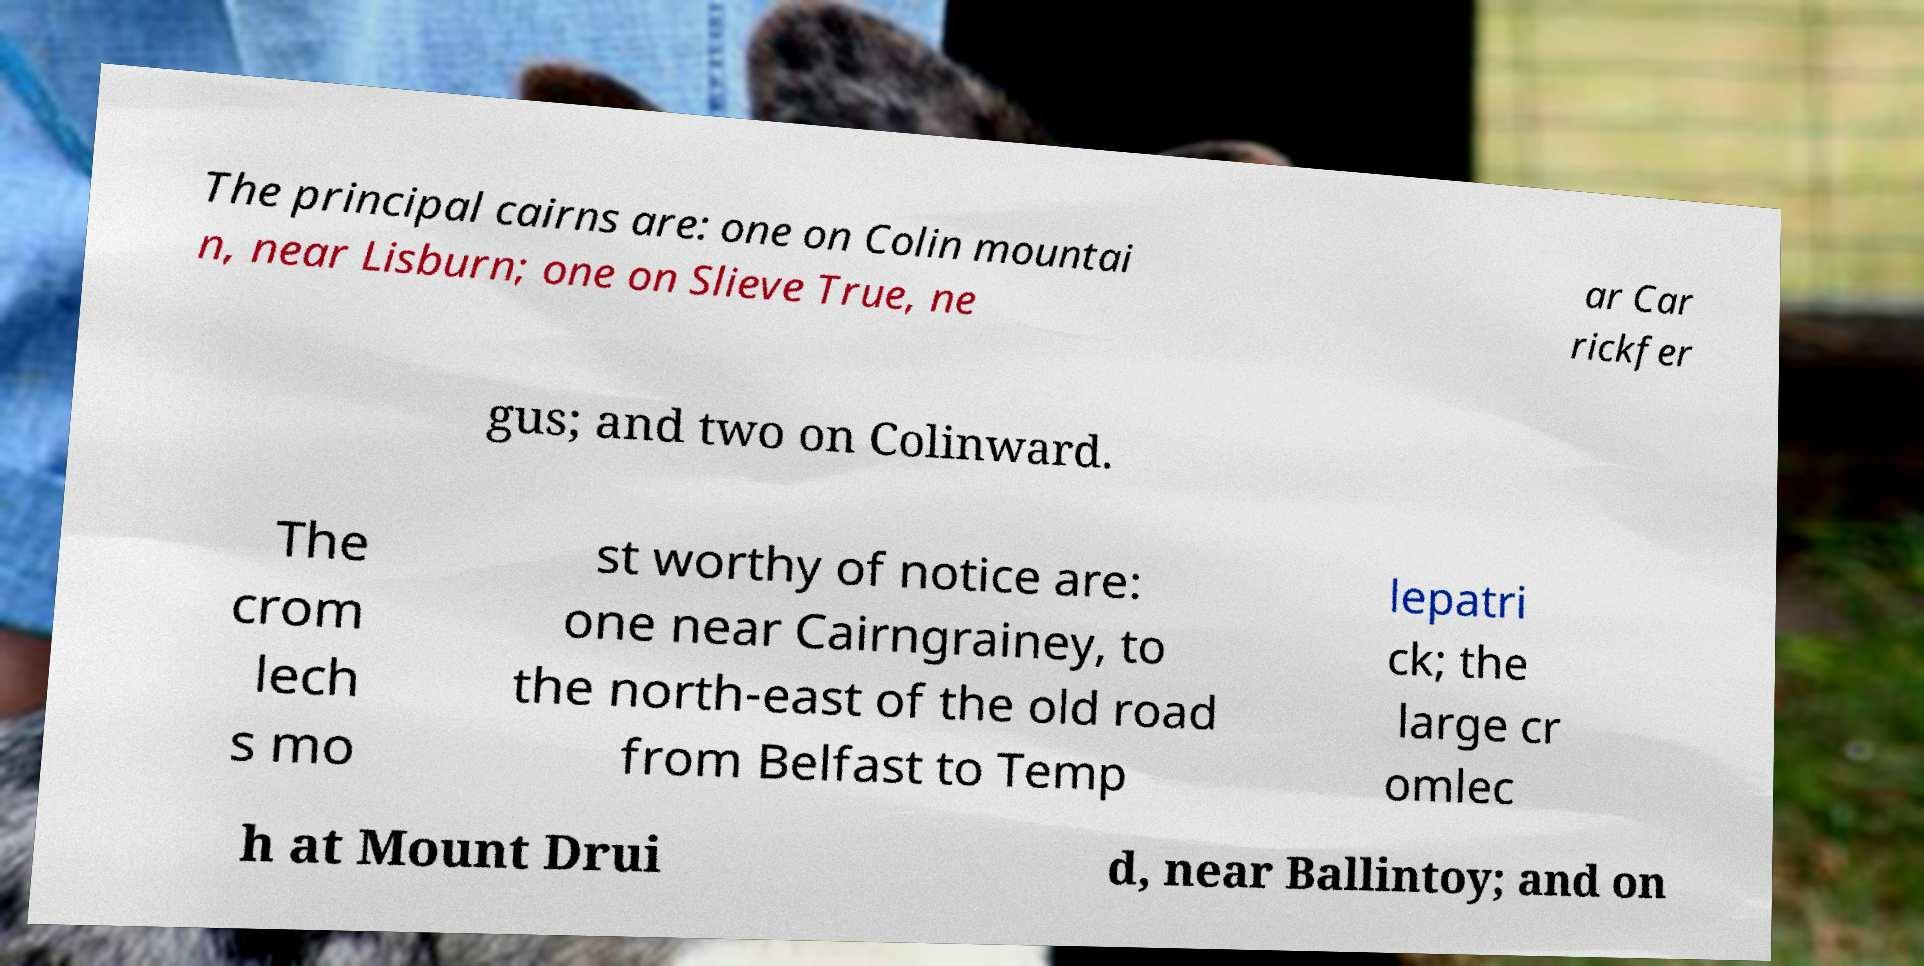There's text embedded in this image that I need extracted. Can you transcribe it verbatim? The principal cairns are: one on Colin mountai n, near Lisburn; one on Slieve True, ne ar Car rickfer gus; and two on Colinward. The crom lech s mo st worthy of notice are: one near Cairngrainey, to the north-east of the old road from Belfast to Temp lepatri ck; the large cr omlec h at Mount Drui d, near Ballintoy; and on 